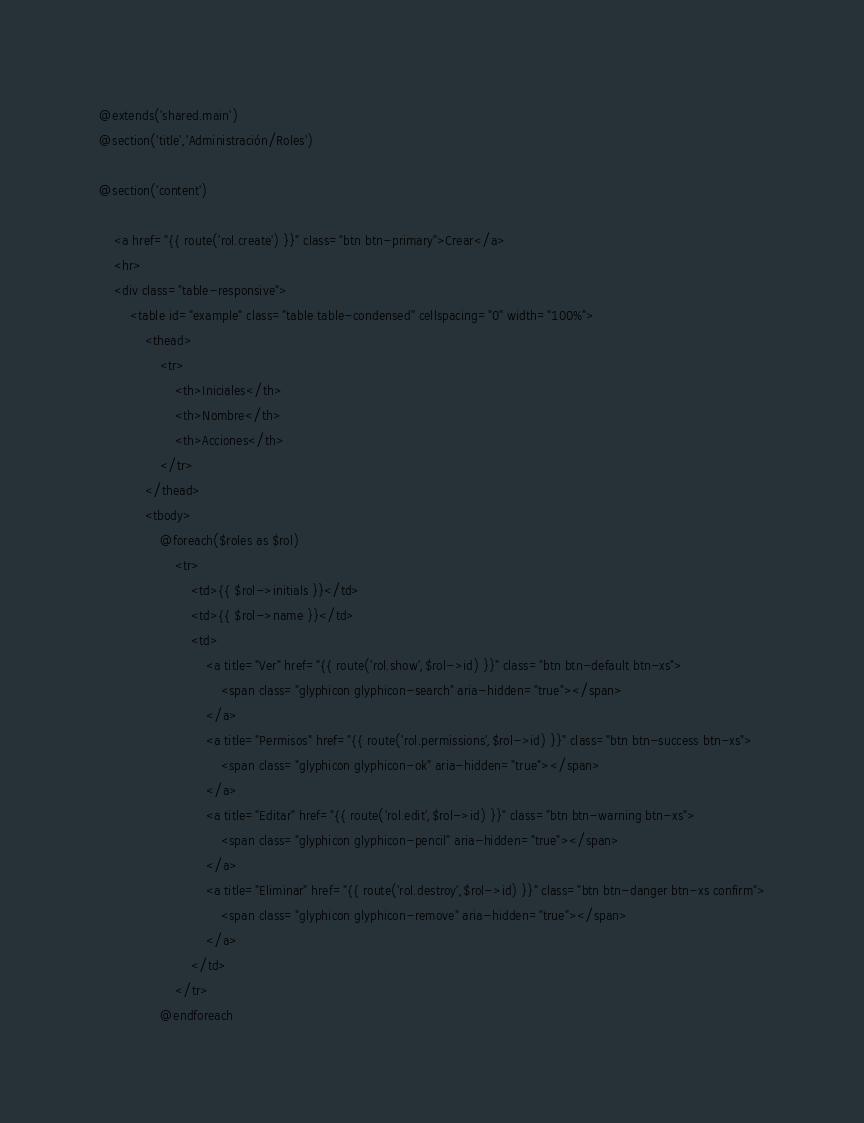Convert code to text. <code><loc_0><loc_0><loc_500><loc_500><_PHP_>@extends('shared.main')
@section('title','Administración/Roles')

@section('content')

	<a href="{{ route('rol.create') }}" class="btn btn-primary">Crear</a>	
	<hr>
	<div class="table-responsive">
		<table id="example" class="table table-condensed" cellspacing="0" width="100%">
			<thead>
		        <tr>
		        	<th>Iniciales</th>
					<th>Nombre</th>
					<th>Acciones</th>
				</tr>
			</thead>
			<tbody>
 				@foreach($roles as $rol)
					<tr>
						<td>{{ $rol->initials }}</td>
						<td>{{ $rol->name }}</td>
						<td>								
							<a title="Ver" href="{{ route('rol.show',$rol->id) }}" class="btn btn-default btn-xs">
								<span class="glyphicon glyphicon-search" aria-hidden="true"></span>
							</a>
							<a title="Permisos" href="{{ route('rol.permissions',$rol->id) }}" class="btn btn-success btn-xs">
								<span class="glyphicon glyphicon-ok" aria-hidden="true"></span>
							</a>
							<a title="Editar" href="{{ route('rol.edit',$rol->id) }}" class="btn btn-warning btn-xs">
								<span class="glyphicon glyphicon-pencil" aria-hidden="true"></span>
							</a>
							<a title="Eliminar" href="{{ route('rol.destroy',$rol->id) }}" class="btn btn-danger btn-xs confirm">
								<span class="glyphicon glyphicon-remove" aria-hidden="true"></span>
							</a>
						</td>
					</tr>
				@endforeach </code> 